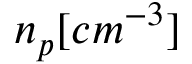Convert formula to latex. <formula><loc_0><loc_0><loc_500><loc_500>n _ { p } [ c m ^ { - 3 } ]</formula> 